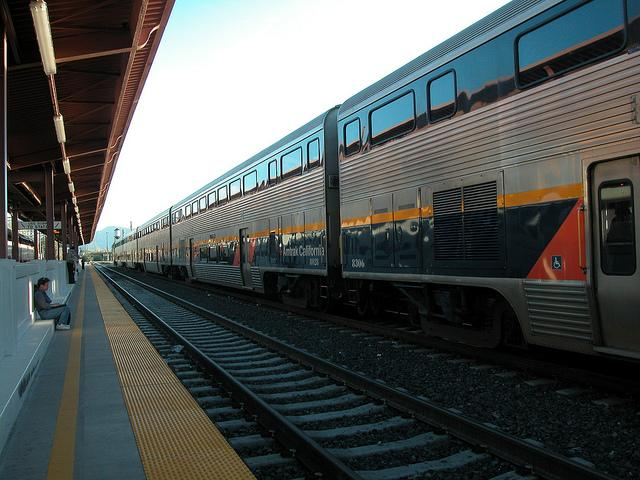What color is the triangle halves on the side of the bus next to the luggage holders? orange 